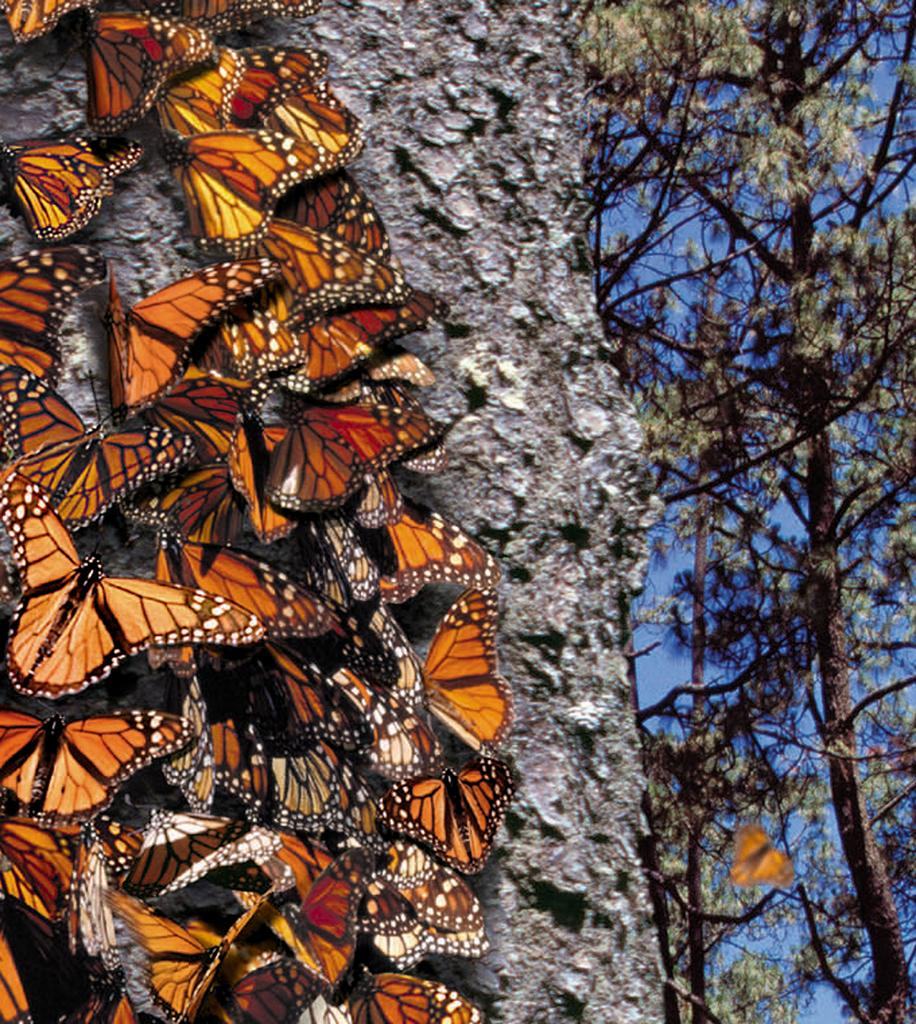What type of creatures can be seen on the left side of the image? There are butterflies on the left side of the image. What type of vegetation is on the right side of the image? There are trees on the right side of the image. Where can the expert be found in the image? There is no expert present in the image; it features butterflies and trees. What type of stamp can be seen on the butterflies in the image? There are no stamps on the butterflies in the image; they are depicted as natural creatures. 